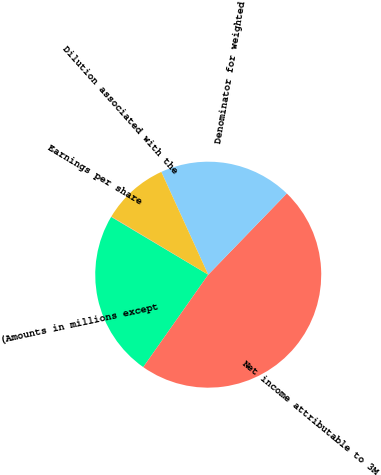Convert chart to OTSL. <chart><loc_0><loc_0><loc_500><loc_500><pie_chart><fcel>(Amounts in millions except<fcel>Net income attributable to 3M<fcel>Denominator for weighted<fcel>Dilution associated with the<fcel>Earnings per share<nl><fcel>23.8%<fcel>47.52%<fcel>19.05%<fcel>9.56%<fcel>0.07%<nl></chart> 